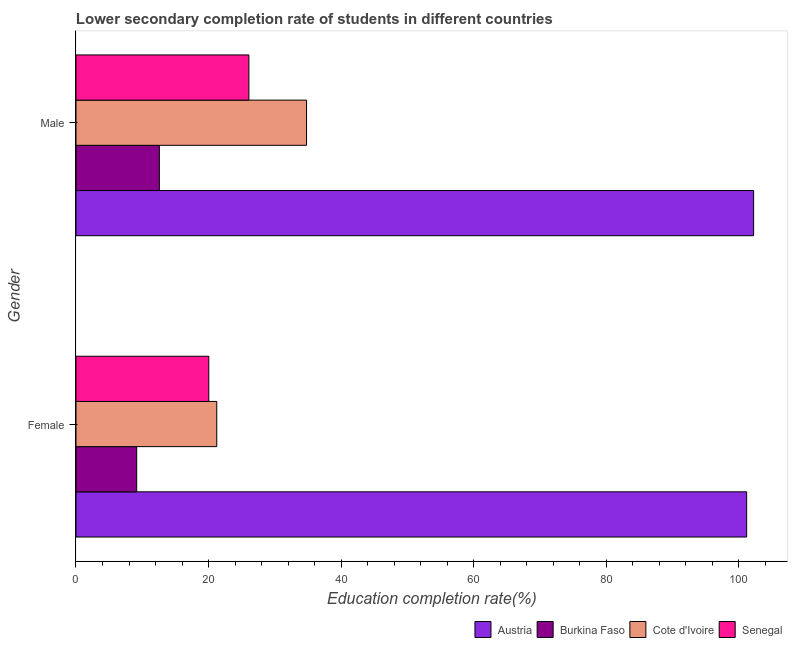How many groups of bars are there?
Your response must be concise. 2. Are the number of bars per tick equal to the number of legend labels?
Keep it short and to the point. Yes. How many bars are there on the 1st tick from the top?
Your answer should be compact. 4. What is the education completion rate of male students in Burkina Faso?
Offer a terse response. 12.58. Across all countries, what is the maximum education completion rate of female students?
Provide a succinct answer. 101.22. Across all countries, what is the minimum education completion rate of female students?
Offer a very short reply. 9.16. In which country was the education completion rate of female students minimum?
Ensure brevity in your answer.  Burkina Faso. What is the total education completion rate of female students in the graph?
Offer a very short reply. 151.67. What is the difference between the education completion rate of female students in Senegal and that in Burkina Faso?
Ensure brevity in your answer.  10.88. What is the difference between the education completion rate of female students in Austria and the education completion rate of male students in Senegal?
Your answer should be compact. 75.13. What is the average education completion rate of female students per country?
Your response must be concise. 37.92. What is the difference between the education completion rate of male students and education completion rate of female students in Burkina Faso?
Keep it short and to the point. 3.42. What is the ratio of the education completion rate of male students in Burkina Faso to that in Cote d'Ivoire?
Your response must be concise. 0.36. In how many countries, is the education completion rate of male students greater than the average education completion rate of male students taken over all countries?
Your answer should be compact. 1. What does the 4th bar from the top in Male represents?
Give a very brief answer. Austria. What does the 2nd bar from the bottom in Female represents?
Keep it short and to the point. Burkina Faso. How many bars are there?
Your response must be concise. 8. Are all the bars in the graph horizontal?
Offer a terse response. Yes. How many countries are there in the graph?
Your answer should be compact. 4. Does the graph contain any zero values?
Provide a short and direct response. No. How many legend labels are there?
Your answer should be very brief. 4. How are the legend labels stacked?
Your answer should be very brief. Horizontal. What is the title of the graph?
Offer a very short reply. Lower secondary completion rate of students in different countries. Does "High income: nonOECD" appear as one of the legend labels in the graph?
Your answer should be very brief. No. What is the label or title of the X-axis?
Keep it short and to the point. Education completion rate(%). What is the label or title of the Y-axis?
Offer a terse response. Gender. What is the Education completion rate(%) in Austria in Female?
Provide a short and direct response. 101.22. What is the Education completion rate(%) in Burkina Faso in Female?
Keep it short and to the point. 9.16. What is the Education completion rate(%) in Cote d'Ivoire in Female?
Offer a very short reply. 21.24. What is the Education completion rate(%) in Senegal in Female?
Provide a short and direct response. 20.04. What is the Education completion rate(%) in Austria in Male?
Your answer should be very brief. 102.27. What is the Education completion rate(%) of Burkina Faso in Male?
Ensure brevity in your answer.  12.58. What is the Education completion rate(%) in Cote d'Ivoire in Male?
Offer a very short reply. 34.8. What is the Education completion rate(%) of Senegal in Male?
Ensure brevity in your answer.  26.09. Across all Gender, what is the maximum Education completion rate(%) of Austria?
Your answer should be very brief. 102.27. Across all Gender, what is the maximum Education completion rate(%) of Burkina Faso?
Keep it short and to the point. 12.58. Across all Gender, what is the maximum Education completion rate(%) of Cote d'Ivoire?
Your response must be concise. 34.8. Across all Gender, what is the maximum Education completion rate(%) of Senegal?
Your response must be concise. 26.09. Across all Gender, what is the minimum Education completion rate(%) in Austria?
Offer a terse response. 101.22. Across all Gender, what is the minimum Education completion rate(%) in Burkina Faso?
Provide a succinct answer. 9.16. Across all Gender, what is the minimum Education completion rate(%) in Cote d'Ivoire?
Keep it short and to the point. 21.24. Across all Gender, what is the minimum Education completion rate(%) of Senegal?
Offer a very short reply. 20.04. What is the total Education completion rate(%) of Austria in the graph?
Offer a very short reply. 203.49. What is the total Education completion rate(%) in Burkina Faso in the graph?
Your answer should be very brief. 21.74. What is the total Education completion rate(%) in Cote d'Ivoire in the graph?
Your answer should be very brief. 56.04. What is the total Education completion rate(%) of Senegal in the graph?
Make the answer very short. 46.14. What is the difference between the Education completion rate(%) of Austria in Female and that in Male?
Give a very brief answer. -1.05. What is the difference between the Education completion rate(%) of Burkina Faso in Female and that in Male?
Your response must be concise. -3.42. What is the difference between the Education completion rate(%) in Cote d'Ivoire in Female and that in Male?
Keep it short and to the point. -13.55. What is the difference between the Education completion rate(%) in Senegal in Female and that in Male?
Offer a very short reply. -6.05. What is the difference between the Education completion rate(%) in Austria in Female and the Education completion rate(%) in Burkina Faso in Male?
Provide a short and direct response. 88.64. What is the difference between the Education completion rate(%) in Austria in Female and the Education completion rate(%) in Cote d'Ivoire in Male?
Your response must be concise. 66.42. What is the difference between the Education completion rate(%) of Austria in Female and the Education completion rate(%) of Senegal in Male?
Offer a terse response. 75.13. What is the difference between the Education completion rate(%) of Burkina Faso in Female and the Education completion rate(%) of Cote d'Ivoire in Male?
Provide a succinct answer. -25.64. What is the difference between the Education completion rate(%) of Burkina Faso in Female and the Education completion rate(%) of Senegal in Male?
Your response must be concise. -16.93. What is the difference between the Education completion rate(%) in Cote d'Ivoire in Female and the Education completion rate(%) in Senegal in Male?
Provide a short and direct response. -4.85. What is the average Education completion rate(%) of Austria per Gender?
Your answer should be compact. 101.74. What is the average Education completion rate(%) in Burkina Faso per Gender?
Keep it short and to the point. 10.87. What is the average Education completion rate(%) of Cote d'Ivoire per Gender?
Your response must be concise. 28.02. What is the average Education completion rate(%) of Senegal per Gender?
Keep it short and to the point. 23.07. What is the difference between the Education completion rate(%) in Austria and Education completion rate(%) in Burkina Faso in Female?
Offer a terse response. 92.06. What is the difference between the Education completion rate(%) in Austria and Education completion rate(%) in Cote d'Ivoire in Female?
Your answer should be very brief. 79.98. What is the difference between the Education completion rate(%) in Austria and Education completion rate(%) in Senegal in Female?
Offer a very short reply. 81.18. What is the difference between the Education completion rate(%) of Burkina Faso and Education completion rate(%) of Cote d'Ivoire in Female?
Provide a short and direct response. -12.08. What is the difference between the Education completion rate(%) in Burkina Faso and Education completion rate(%) in Senegal in Female?
Offer a terse response. -10.88. What is the difference between the Education completion rate(%) of Cote d'Ivoire and Education completion rate(%) of Senegal in Female?
Keep it short and to the point. 1.2. What is the difference between the Education completion rate(%) in Austria and Education completion rate(%) in Burkina Faso in Male?
Your answer should be compact. 89.69. What is the difference between the Education completion rate(%) of Austria and Education completion rate(%) of Cote d'Ivoire in Male?
Make the answer very short. 67.47. What is the difference between the Education completion rate(%) in Austria and Education completion rate(%) in Senegal in Male?
Make the answer very short. 76.17. What is the difference between the Education completion rate(%) of Burkina Faso and Education completion rate(%) of Cote d'Ivoire in Male?
Provide a succinct answer. -22.21. What is the difference between the Education completion rate(%) in Burkina Faso and Education completion rate(%) in Senegal in Male?
Ensure brevity in your answer.  -13.51. What is the difference between the Education completion rate(%) in Cote d'Ivoire and Education completion rate(%) in Senegal in Male?
Provide a succinct answer. 8.7. What is the ratio of the Education completion rate(%) in Austria in Female to that in Male?
Your response must be concise. 0.99. What is the ratio of the Education completion rate(%) of Burkina Faso in Female to that in Male?
Provide a short and direct response. 0.73. What is the ratio of the Education completion rate(%) in Cote d'Ivoire in Female to that in Male?
Your response must be concise. 0.61. What is the ratio of the Education completion rate(%) of Senegal in Female to that in Male?
Ensure brevity in your answer.  0.77. What is the difference between the highest and the second highest Education completion rate(%) of Austria?
Offer a very short reply. 1.05. What is the difference between the highest and the second highest Education completion rate(%) of Burkina Faso?
Give a very brief answer. 3.42. What is the difference between the highest and the second highest Education completion rate(%) in Cote d'Ivoire?
Offer a terse response. 13.55. What is the difference between the highest and the second highest Education completion rate(%) in Senegal?
Your answer should be compact. 6.05. What is the difference between the highest and the lowest Education completion rate(%) of Austria?
Offer a terse response. 1.05. What is the difference between the highest and the lowest Education completion rate(%) of Burkina Faso?
Provide a succinct answer. 3.42. What is the difference between the highest and the lowest Education completion rate(%) in Cote d'Ivoire?
Make the answer very short. 13.55. What is the difference between the highest and the lowest Education completion rate(%) of Senegal?
Your answer should be very brief. 6.05. 